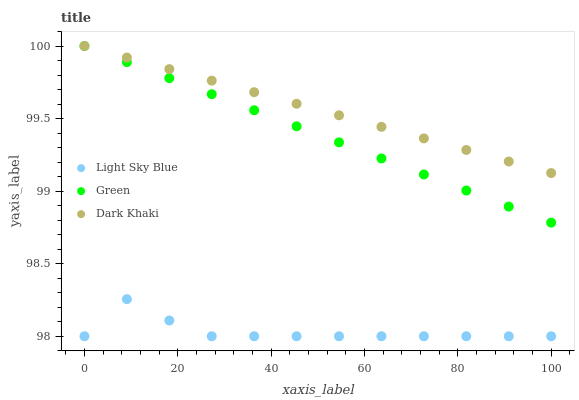Does Light Sky Blue have the minimum area under the curve?
Answer yes or no. Yes. Does Dark Khaki have the maximum area under the curve?
Answer yes or no. Yes. Does Green have the minimum area under the curve?
Answer yes or no. No. Does Green have the maximum area under the curve?
Answer yes or no. No. Is Green the smoothest?
Answer yes or no. Yes. Is Light Sky Blue the roughest?
Answer yes or no. Yes. Is Light Sky Blue the smoothest?
Answer yes or no. No. Is Green the roughest?
Answer yes or no. No. Does Light Sky Blue have the lowest value?
Answer yes or no. Yes. Does Green have the lowest value?
Answer yes or no. No. Does Green have the highest value?
Answer yes or no. Yes. Does Light Sky Blue have the highest value?
Answer yes or no. No. Is Light Sky Blue less than Dark Khaki?
Answer yes or no. Yes. Is Dark Khaki greater than Light Sky Blue?
Answer yes or no. Yes. Does Green intersect Dark Khaki?
Answer yes or no. Yes. Is Green less than Dark Khaki?
Answer yes or no. No. Is Green greater than Dark Khaki?
Answer yes or no. No. Does Light Sky Blue intersect Dark Khaki?
Answer yes or no. No. 